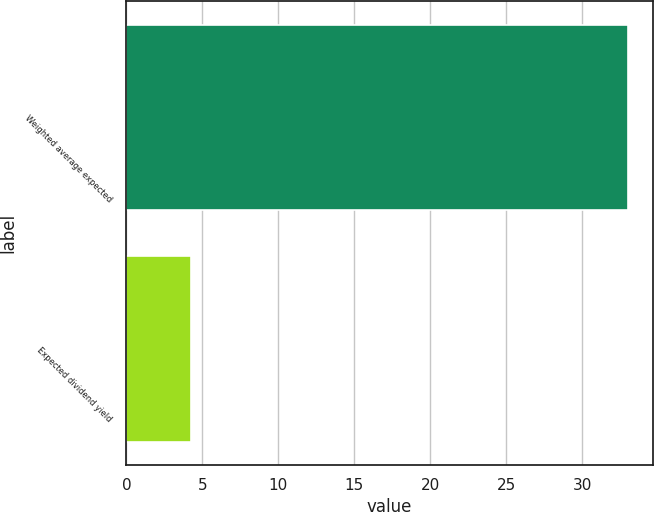Convert chart. <chart><loc_0><loc_0><loc_500><loc_500><bar_chart><fcel>Weighted average expected<fcel>Expected dividend yield<nl><fcel>33<fcel>4.27<nl></chart> 